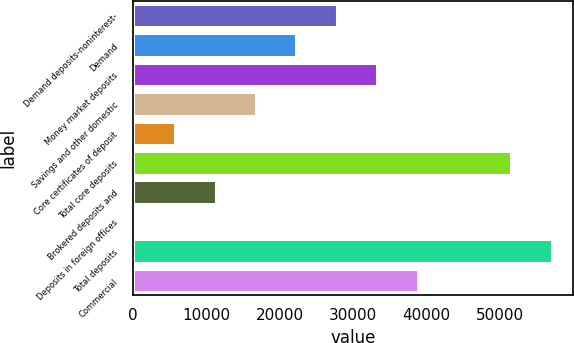<chart> <loc_0><loc_0><loc_500><loc_500><bar_chart><fcel>Demand deposits-noninterest-<fcel>Demand<fcel>Money market deposits<fcel>Savings and other domestic<fcel>Core certificates of deposit<fcel>Total core deposits<fcel>Brokered deposits and<fcel>Deposits in foreign offices<fcel>Total deposits<fcel>Commercial<nl><fcel>27781.5<fcel>22278.8<fcel>33284.2<fcel>16776.1<fcel>5770.7<fcel>51582<fcel>11273.4<fcel>268<fcel>57084.7<fcel>38786.9<nl></chart> 